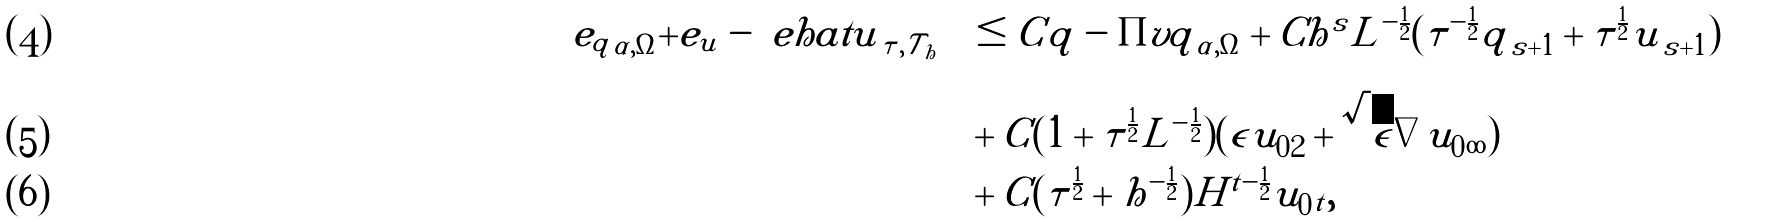<formula> <loc_0><loc_0><loc_500><loc_500>\| e _ { q } \| _ { \alpha , \Omega } + \| e _ { u } - \ e h a t u \| _ { \tau , \mathcal { T } _ { h } } & \leq C \| q - \Pi v q \| _ { \alpha , \Omega } + C h ^ { s } L ^ { - \frac { 1 } { 2 } } ( \tau ^ { - \frac { 1 } { 2 } } \| q \| _ { s + 1 } + \tau ^ { \frac { 1 } { 2 } } \| u \| _ { s + 1 } ) \\ & + C ( 1 + \tau ^ { \frac { 1 } { 2 } } L ^ { - \frac { 1 } { 2 } } ) ( \epsilon \| u _ { 0 } \| _ { 2 } + \sqrt { \epsilon } \| \nabla u _ { 0 } \| _ { \infty } ) \\ & + C ( \tau ^ { \frac { 1 } { 2 } } + h ^ { - \frac { 1 } { 2 } } ) H ^ { t - \frac { 1 } { 2 } } \| u _ { 0 } \| _ { t } ,</formula> 